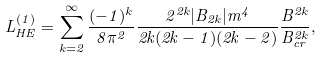Convert formula to latex. <formula><loc_0><loc_0><loc_500><loc_500>L _ { H E } ^ { ( 1 ) } = \sum _ { k = 2 } ^ { \infty } \frac { ( - 1 ) ^ { k } } { 8 \pi ^ { 2 } } \frac { 2 ^ { 2 k } | B _ { 2 k } | m ^ { 4 } } { 2 k ( 2 k - 1 ) ( 2 k - 2 ) } \frac { B ^ { 2 k } } { B _ { c r } ^ { 2 k } } ,</formula> 